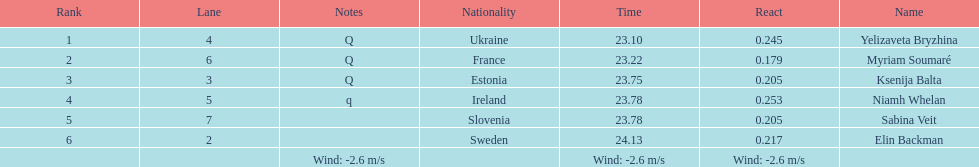What number of last names start with "b"? 3. 